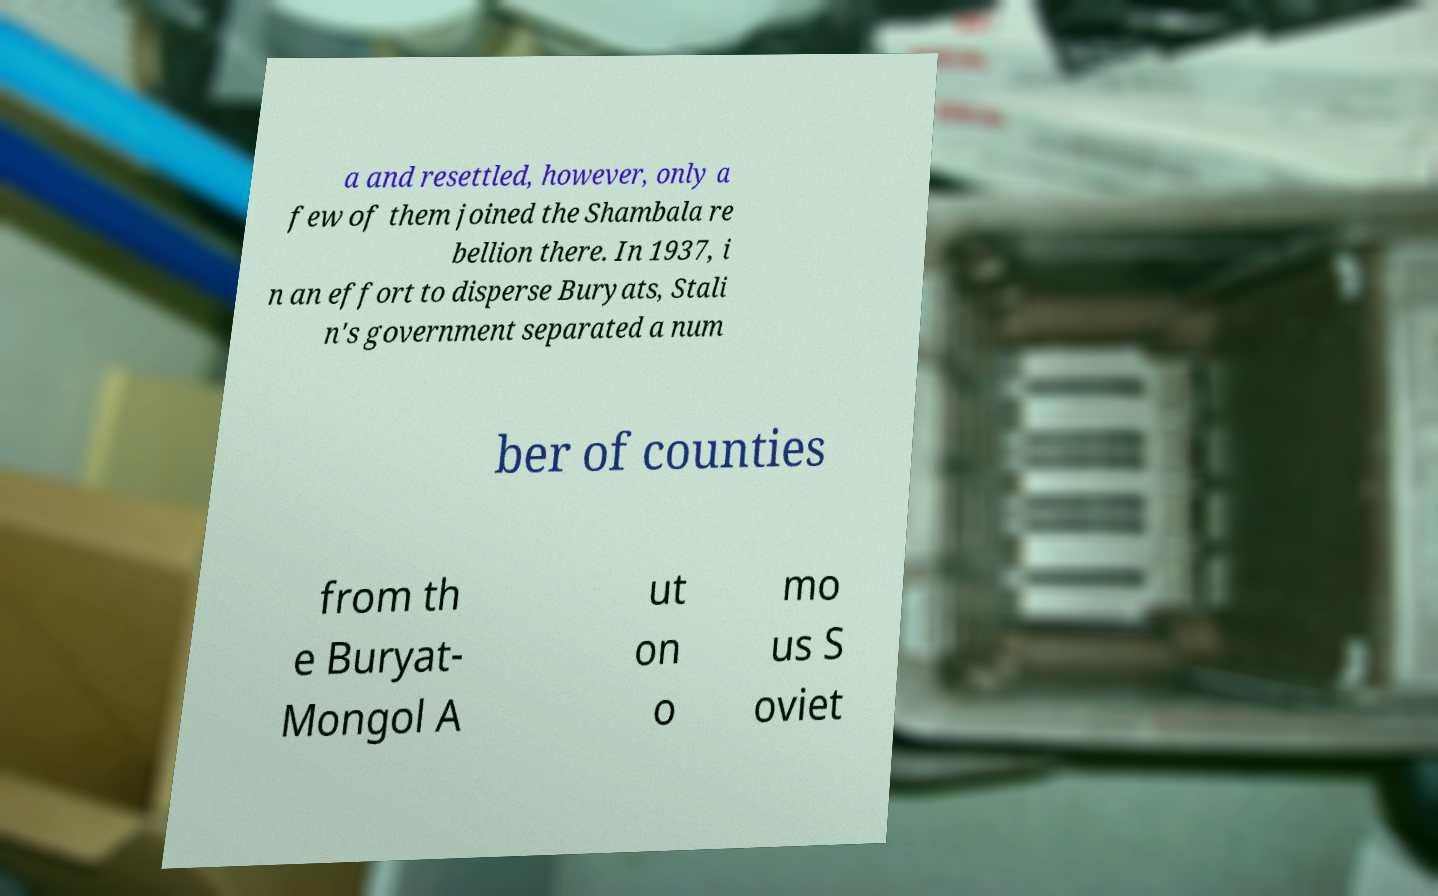Can you accurately transcribe the text from the provided image for me? a and resettled, however, only a few of them joined the Shambala re bellion there. In 1937, i n an effort to disperse Buryats, Stali n's government separated a num ber of counties from th e Buryat- Mongol A ut on o mo us S oviet 